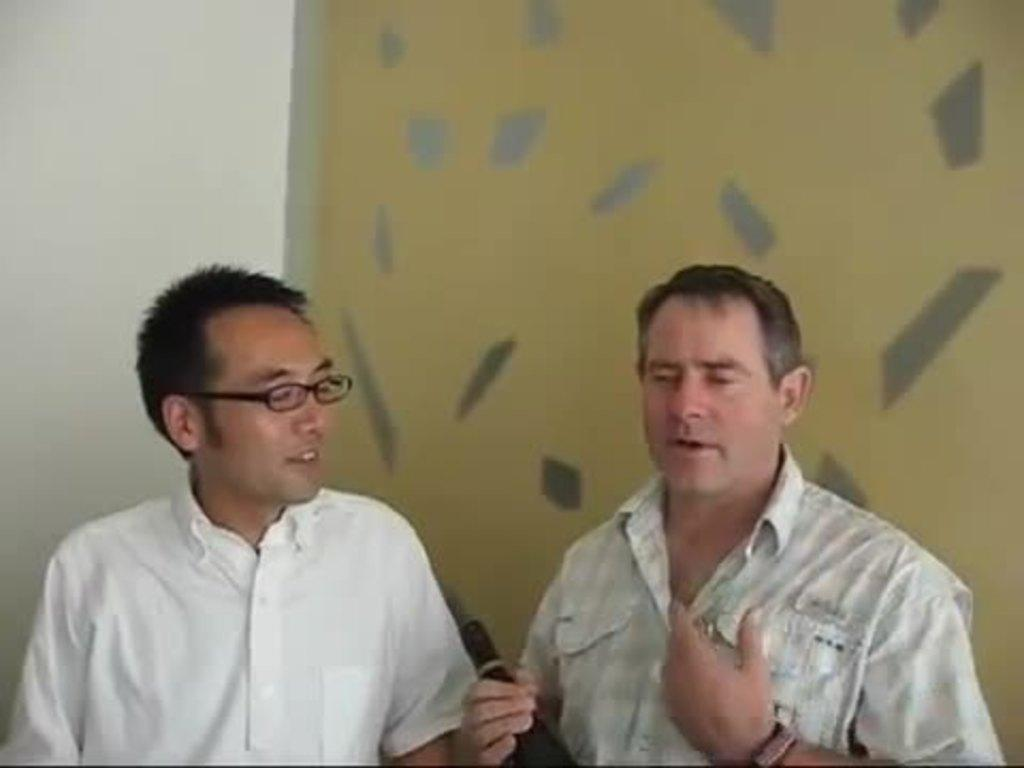How many people are in the image? There are two men in the image. What is one of the men holding? One of the men is holding a bottle. What can be seen in the background of the image? There is a wall in the background of the image. What type of eggs can be seen on the wall in the image? There are no eggs present in the image; only two men and a wall are visible. 